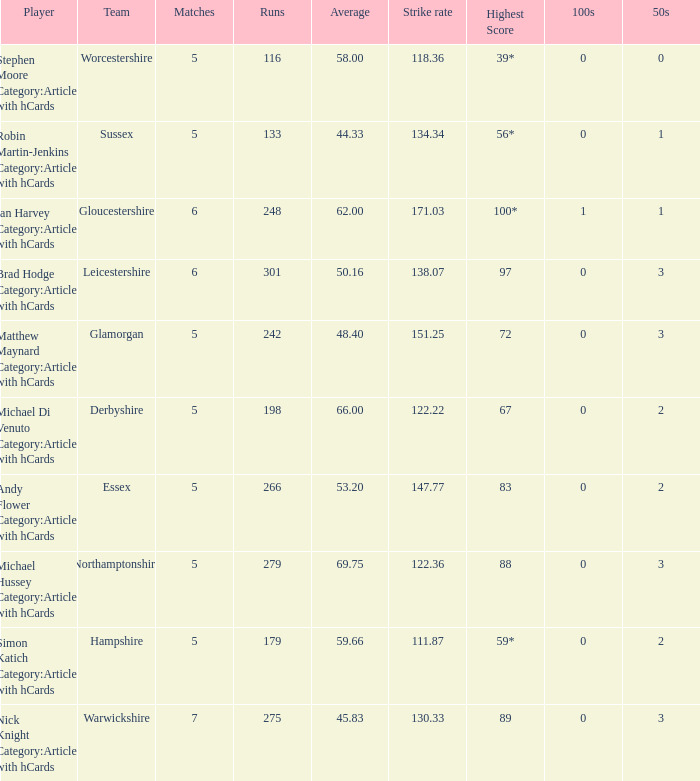If the average is 50.16, who is the player? Brad Hodge Category:Articles with hCards. 